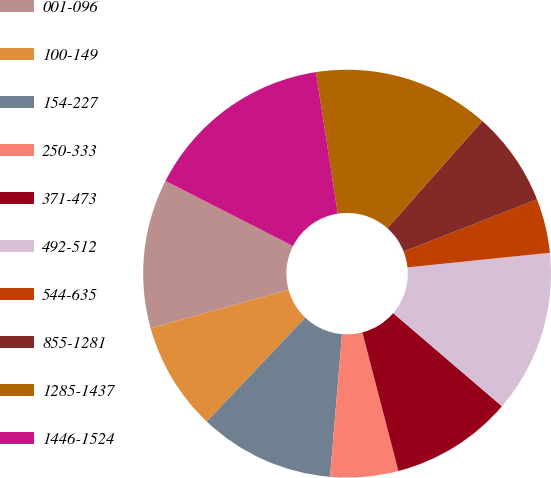Convert chart to OTSL. <chart><loc_0><loc_0><loc_500><loc_500><pie_chart><fcel>001-096<fcel>100-149<fcel>154-227<fcel>250-333<fcel>371-473<fcel>492-512<fcel>544-635<fcel>855-1281<fcel>1285-1437<fcel>1446-1524<nl><fcel>11.83%<fcel>8.6%<fcel>10.75%<fcel>5.38%<fcel>9.68%<fcel>12.9%<fcel>4.3%<fcel>7.53%<fcel>13.98%<fcel>15.05%<nl></chart> 